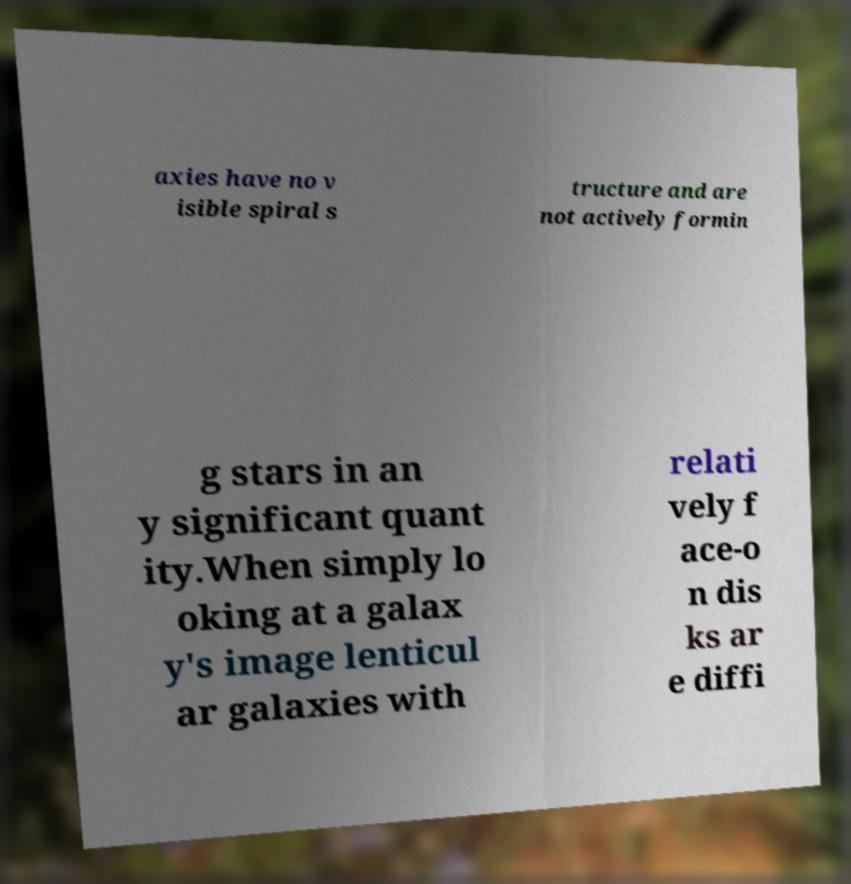What messages or text are displayed in this image? I need them in a readable, typed format. axies have no v isible spiral s tructure and are not actively formin g stars in an y significant quant ity.When simply lo oking at a galax y's image lenticul ar galaxies with relati vely f ace-o n dis ks ar e diffi 